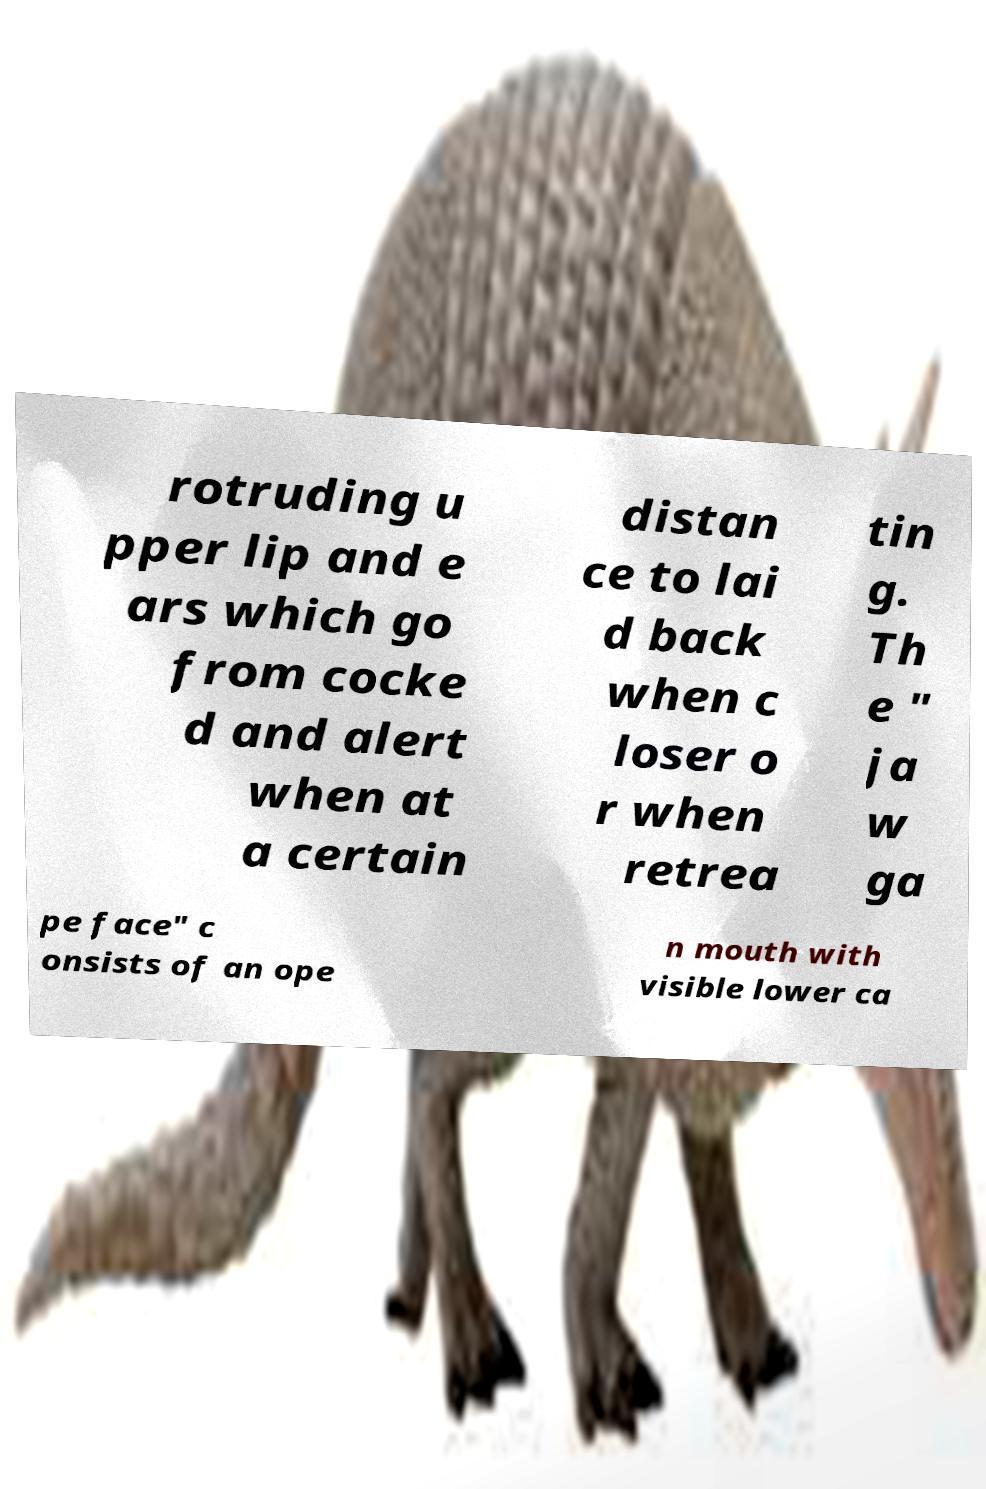There's text embedded in this image that I need extracted. Can you transcribe it verbatim? rotruding u pper lip and e ars which go from cocke d and alert when at a certain distan ce to lai d back when c loser o r when retrea tin g. Th e " ja w ga pe face" c onsists of an ope n mouth with visible lower ca 